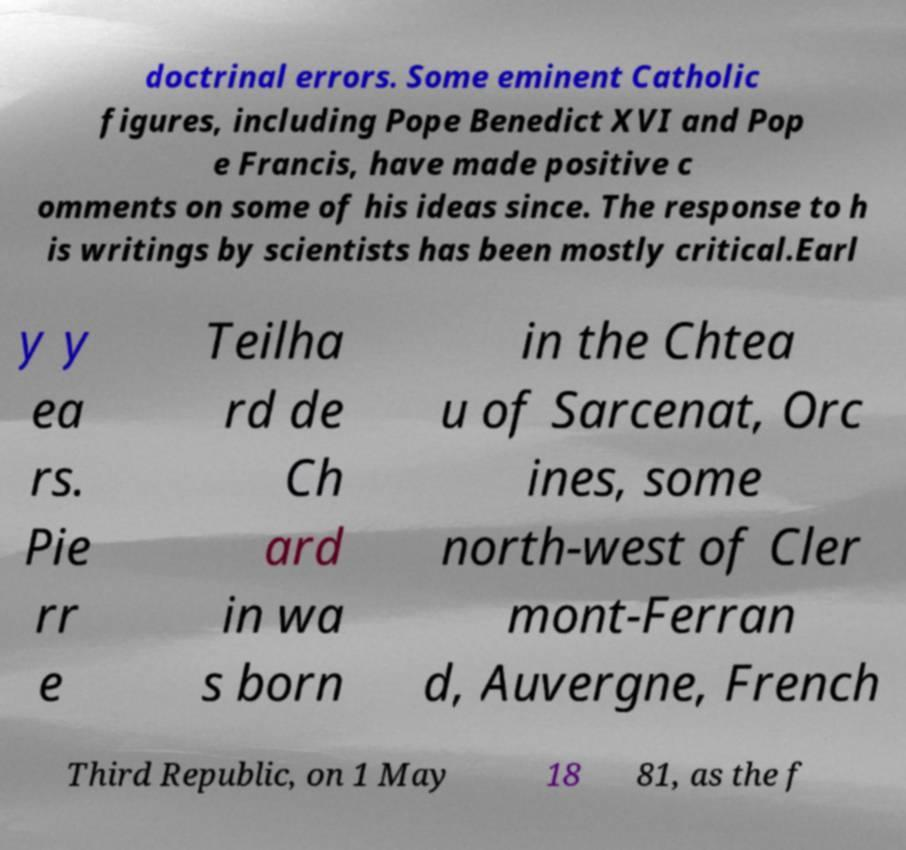Can you read and provide the text displayed in the image?This photo seems to have some interesting text. Can you extract and type it out for me? doctrinal errors. Some eminent Catholic figures, including Pope Benedict XVI and Pop e Francis, have made positive c omments on some of his ideas since. The response to h is writings by scientists has been mostly critical.Earl y y ea rs. Pie rr e Teilha rd de Ch ard in wa s born in the Chtea u of Sarcenat, Orc ines, some north-west of Cler mont-Ferran d, Auvergne, French Third Republic, on 1 May 18 81, as the f 